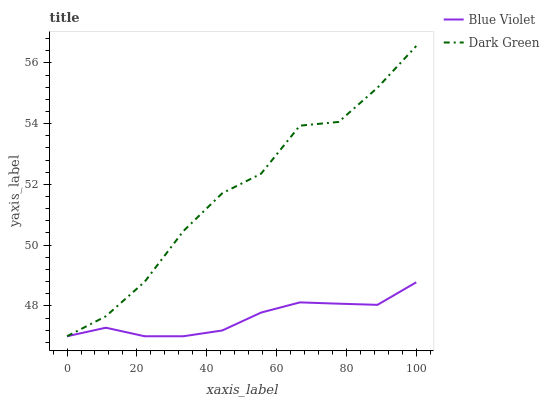Does Blue Violet have the minimum area under the curve?
Answer yes or no. Yes. Does Dark Green have the maximum area under the curve?
Answer yes or no. Yes. Does Dark Green have the minimum area under the curve?
Answer yes or no. No. Is Blue Violet the smoothest?
Answer yes or no. Yes. Is Dark Green the roughest?
Answer yes or no. Yes. Is Dark Green the smoothest?
Answer yes or no. No. Does Blue Violet have the lowest value?
Answer yes or no. Yes. Does Dark Green have the highest value?
Answer yes or no. Yes. Does Dark Green intersect Blue Violet?
Answer yes or no. Yes. Is Dark Green less than Blue Violet?
Answer yes or no. No. Is Dark Green greater than Blue Violet?
Answer yes or no. No. 